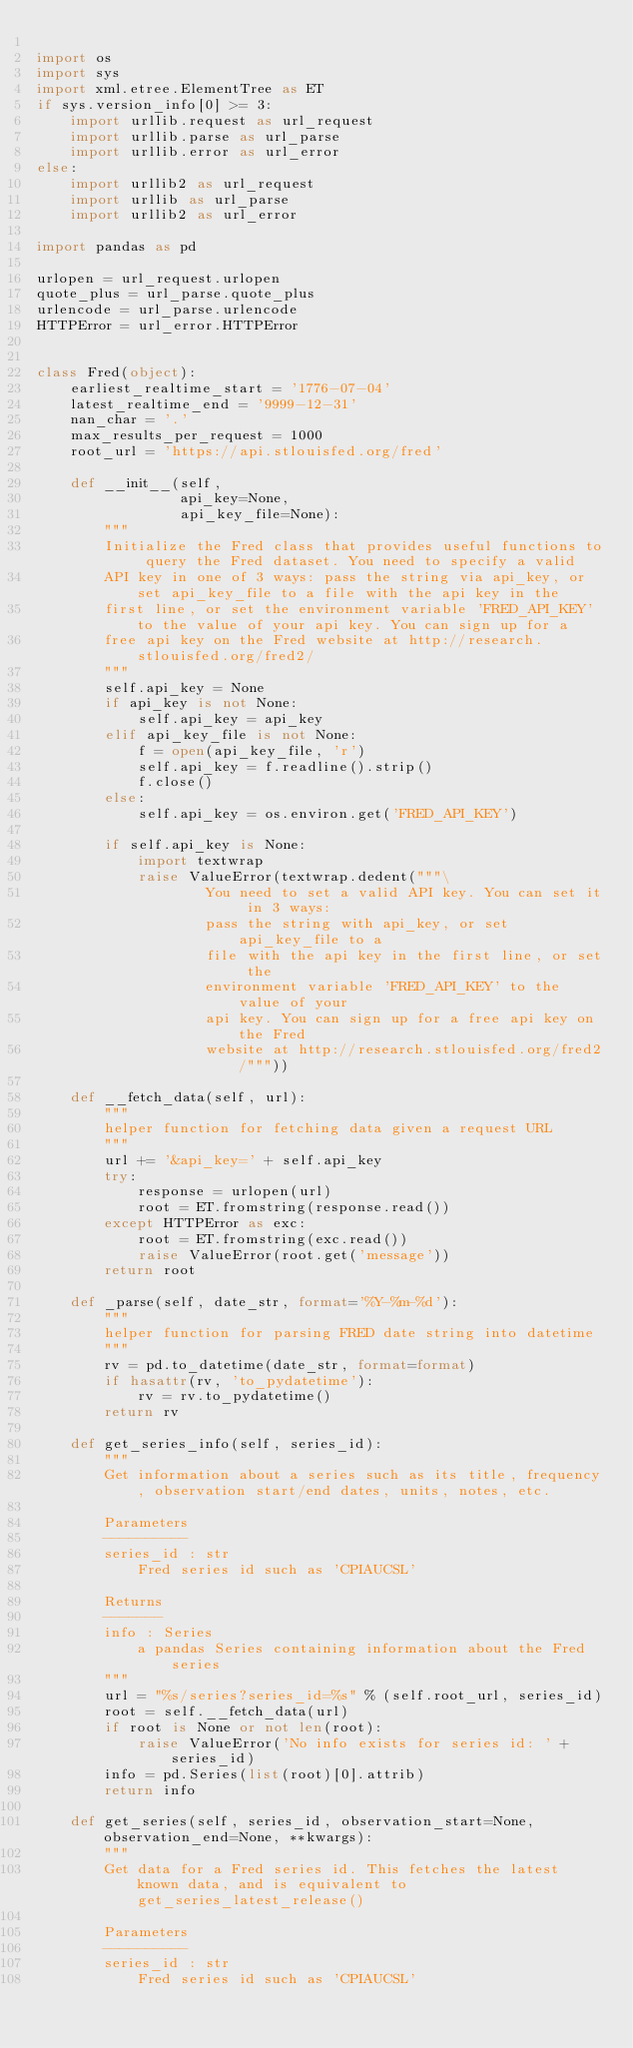<code> <loc_0><loc_0><loc_500><loc_500><_Python_>
import os
import sys
import xml.etree.ElementTree as ET
if sys.version_info[0] >= 3:
    import urllib.request as url_request
    import urllib.parse as url_parse
    import urllib.error as url_error
else:
    import urllib2 as url_request
    import urllib as url_parse
    import urllib2 as url_error

import pandas as pd

urlopen = url_request.urlopen
quote_plus = url_parse.quote_plus
urlencode = url_parse.urlencode
HTTPError = url_error.HTTPError


class Fred(object):
    earliest_realtime_start = '1776-07-04'
    latest_realtime_end = '9999-12-31'
    nan_char = '.'
    max_results_per_request = 1000
    root_url = 'https://api.stlouisfed.org/fred'

    def __init__(self,
                 api_key=None,
                 api_key_file=None):
        """
        Initialize the Fred class that provides useful functions to query the Fred dataset. You need to specify a valid
        API key in one of 3 ways: pass the string via api_key, or set api_key_file to a file with the api key in the
        first line, or set the environment variable 'FRED_API_KEY' to the value of your api key. You can sign up for a
        free api key on the Fred website at http://research.stlouisfed.org/fred2/
        """
        self.api_key = None
        if api_key is not None:
            self.api_key = api_key
        elif api_key_file is not None:
            f = open(api_key_file, 'r')
            self.api_key = f.readline().strip()
            f.close()
        else:
            self.api_key = os.environ.get('FRED_API_KEY')

        if self.api_key is None:
            import textwrap
            raise ValueError(textwrap.dedent("""\
                    You need to set a valid API key. You can set it in 3 ways:
                    pass the string with api_key, or set api_key_file to a
                    file with the api key in the first line, or set the
                    environment variable 'FRED_API_KEY' to the value of your
                    api key. You can sign up for a free api key on the Fred
                    website at http://research.stlouisfed.org/fred2/"""))

    def __fetch_data(self, url):
        """
        helper function for fetching data given a request URL
        """
        url += '&api_key=' + self.api_key
        try:
            response = urlopen(url)
            root = ET.fromstring(response.read())
        except HTTPError as exc:
            root = ET.fromstring(exc.read())
            raise ValueError(root.get('message'))
        return root

    def _parse(self, date_str, format='%Y-%m-%d'):
        """
        helper function for parsing FRED date string into datetime
        """
        rv = pd.to_datetime(date_str, format=format)
        if hasattr(rv, 'to_pydatetime'):
            rv = rv.to_pydatetime()
        return rv

    def get_series_info(self, series_id):
        """
        Get information about a series such as its title, frequency, observation start/end dates, units, notes, etc.

        Parameters
        ----------
        series_id : str
            Fred series id such as 'CPIAUCSL'

        Returns
        -------
        info : Series
            a pandas Series containing information about the Fred series
        """
        url = "%s/series?series_id=%s" % (self.root_url, series_id)
        root = self.__fetch_data(url)
        if root is None or not len(root):
            raise ValueError('No info exists for series id: ' + series_id)
        info = pd.Series(list(root)[0].attrib)
        return info

    def get_series(self, series_id, observation_start=None, observation_end=None, **kwargs):
        """
        Get data for a Fred series id. This fetches the latest known data, and is equivalent to get_series_latest_release()

        Parameters
        ----------
        series_id : str
            Fred series id such as 'CPIAUCSL'</code> 